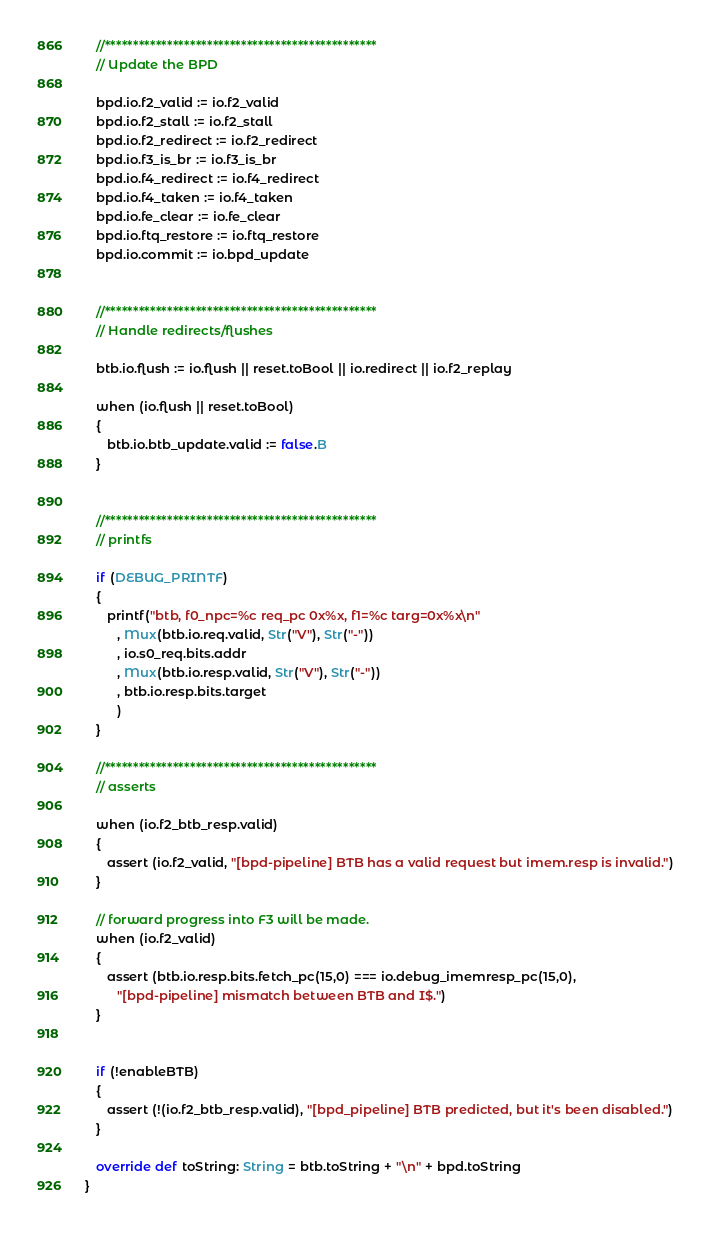<code> <loc_0><loc_0><loc_500><loc_500><_Scala_>
   //************************************************
   // Update the BPD

   bpd.io.f2_valid := io.f2_valid
   bpd.io.f2_stall := io.f2_stall
   bpd.io.f2_redirect := io.f2_redirect
   bpd.io.f3_is_br := io.f3_is_br
   bpd.io.f4_redirect := io.f4_redirect
   bpd.io.f4_taken := io.f4_taken
   bpd.io.fe_clear := io.fe_clear
   bpd.io.ftq_restore := io.ftq_restore
   bpd.io.commit := io.bpd_update


   //************************************************
   // Handle redirects/flushes

   btb.io.flush := io.flush || reset.toBool || io.redirect || io.f2_replay

   when (io.flush || reset.toBool)
   {
      btb.io.btb_update.valid := false.B
   }


   //************************************************
   // printfs

   if (DEBUG_PRINTF)
   {
      printf("btb, f0_npc=%c req_pc 0x%x, f1=%c targ=0x%x\n"
         , Mux(btb.io.req.valid, Str("V"), Str("-"))
         , io.s0_req.bits.addr
         , Mux(btb.io.resp.valid, Str("V"), Str("-"))
         , btb.io.resp.bits.target
         )
   }

   //************************************************
   // asserts

   when (io.f2_btb_resp.valid)
   {
      assert (io.f2_valid, "[bpd-pipeline] BTB has a valid request but imem.resp is invalid.")
   }

   // forward progress into F3 will be made.
   when (io.f2_valid)
   {
      assert (btb.io.resp.bits.fetch_pc(15,0) === io.debug_imemresp_pc(15,0),
         "[bpd-pipeline] mismatch between BTB and I$.")
   }


   if (!enableBTB)
   {
      assert (!(io.f2_btb_resp.valid), "[bpd_pipeline] BTB predicted, but it's been disabled.")
   }

   override def toString: String = btb.toString + "\n" + bpd.toString
}
</code> 